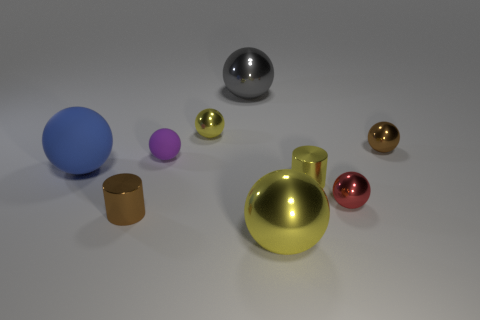Subtract 2 balls. How many balls are left? 5 Subtract all tiny brown balls. How many balls are left? 6 Subtract all purple balls. How many balls are left? 6 Subtract all cyan spheres. Subtract all purple cylinders. How many spheres are left? 7 Subtract all cylinders. How many objects are left? 7 Subtract 1 gray spheres. How many objects are left? 8 Subtract all large yellow metal balls. Subtract all large yellow metal cylinders. How many objects are left? 8 Add 7 small brown metallic cylinders. How many small brown metallic cylinders are left? 8 Add 6 small green cylinders. How many small green cylinders exist? 6 